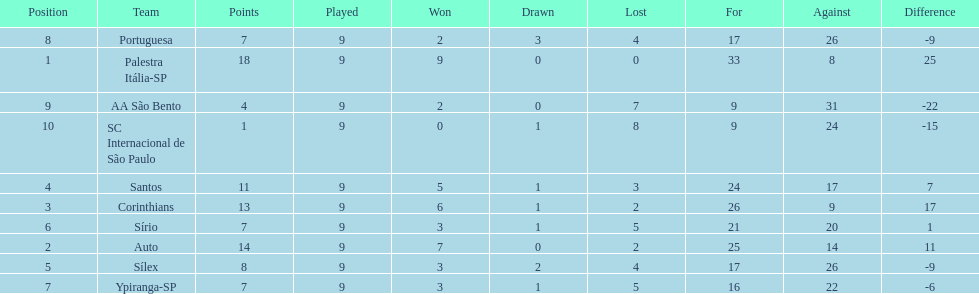How many points were automatically given to the brazilian football team in the year 1926? 14. 